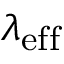<formula> <loc_0><loc_0><loc_500><loc_500>\lambda _ { e f f }</formula> 